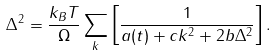<formula> <loc_0><loc_0><loc_500><loc_500>\Delta ^ { 2 } = \frac { k _ { B } T } { \Omega } \sum _ { k } \left [ \frac { 1 } { a ( t ) + c k ^ { 2 } + 2 b \Delta ^ { 2 } } \right ] .</formula> 